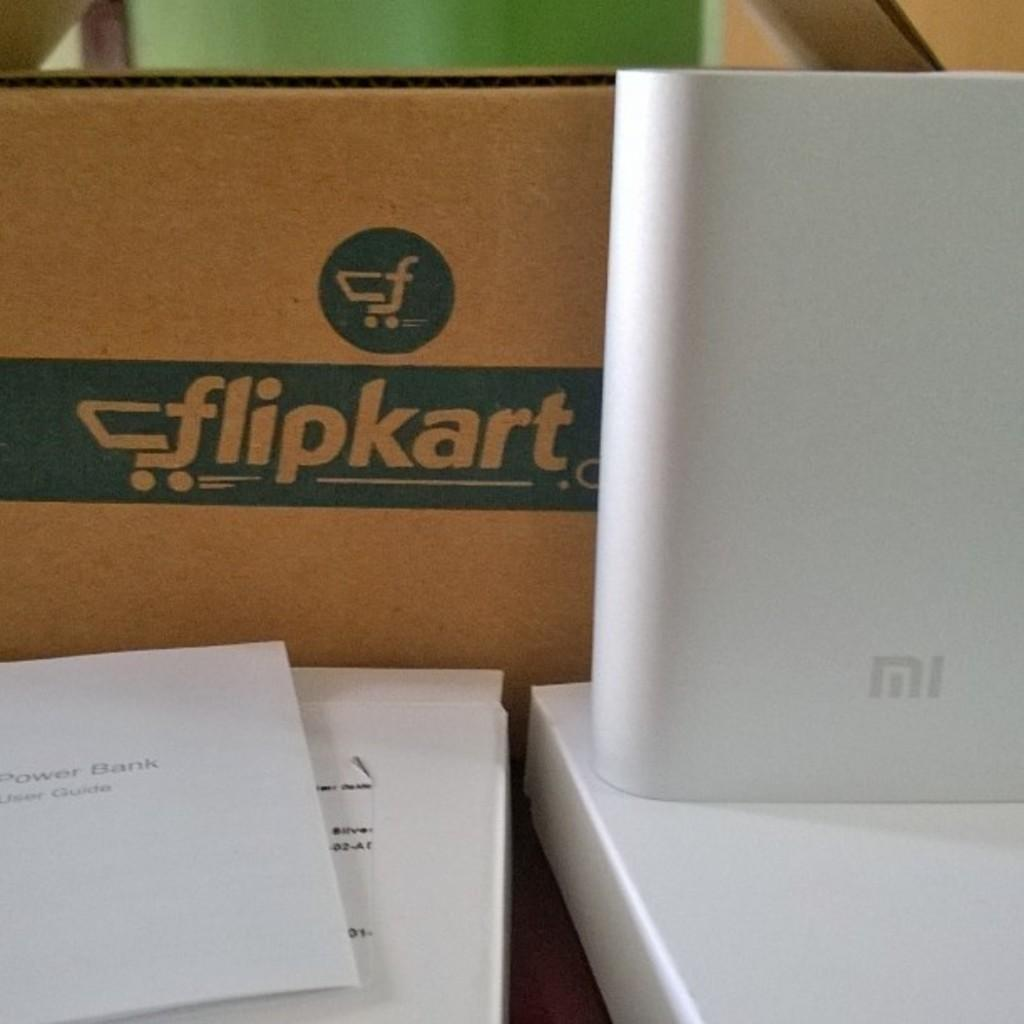<image>
Create a compact narrative representing the image presented. A box that says flipkart sits next to a white electronic device. 